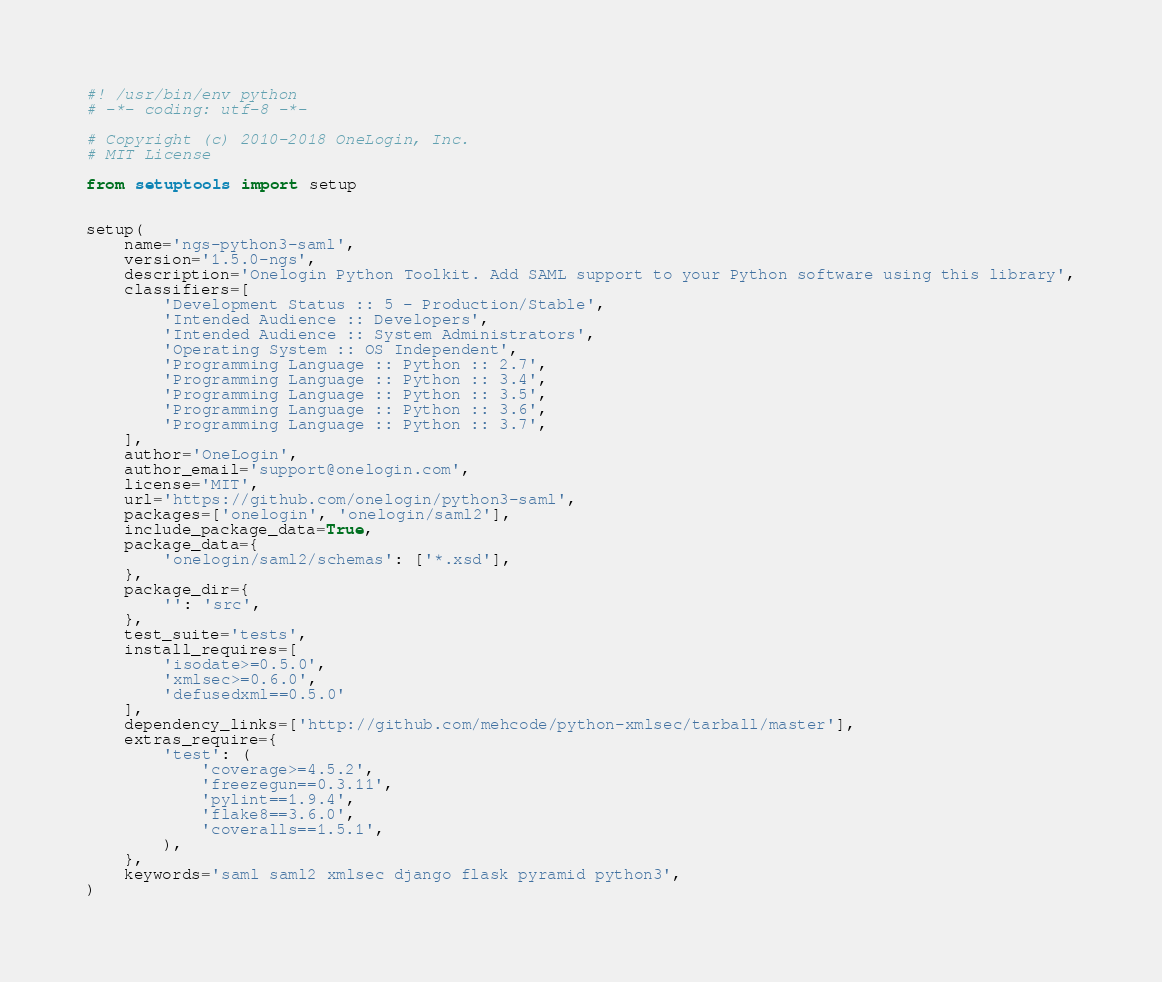<code> <loc_0><loc_0><loc_500><loc_500><_Python_>#! /usr/bin/env python
# -*- coding: utf-8 -*-

# Copyright (c) 2010-2018 OneLogin, Inc.
# MIT License

from setuptools import setup


setup(
    name='ngs-python3-saml',
    version='1.5.0-ngs',
    description='Onelogin Python Toolkit. Add SAML support to your Python software using this library',
    classifiers=[
        'Development Status :: 5 - Production/Stable',
        'Intended Audience :: Developers',
        'Intended Audience :: System Administrators',
        'Operating System :: OS Independent',
        'Programming Language :: Python :: 2.7',
        'Programming Language :: Python :: 3.4',
        'Programming Language :: Python :: 3.5',
        'Programming Language :: Python :: 3.6',
        'Programming Language :: Python :: 3.7',
    ],
    author='OneLogin',
    author_email='support@onelogin.com',
    license='MIT',
    url='https://github.com/onelogin/python3-saml',
    packages=['onelogin', 'onelogin/saml2'],
    include_package_data=True,
    package_data={
        'onelogin/saml2/schemas': ['*.xsd'],
    },
    package_dir={
        '': 'src',
    },
    test_suite='tests',
    install_requires=[
        'isodate>=0.5.0',
        'xmlsec>=0.6.0',
        'defusedxml==0.5.0'
    ],
    dependency_links=['http://github.com/mehcode/python-xmlsec/tarball/master'],
    extras_require={
        'test': (
            'coverage>=4.5.2',
            'freezegun==0.3.11',
            'pylint==1.9.4',
            'flake8==3.6.0',
            'coveralls==1.5.1',
        ),
    },
    keywords='saml saml2 xmlsec django flask pyramid python3',
)
</code> 